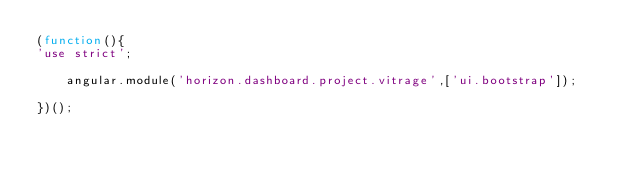<code> <loc_0><loc_0><loc_500><loc_500><_JavaScript_>(function(){
'use strict';

    angular.module('horizon.dashboard.project.vitrage',['ui.bootstrap']);

})();
</code> 